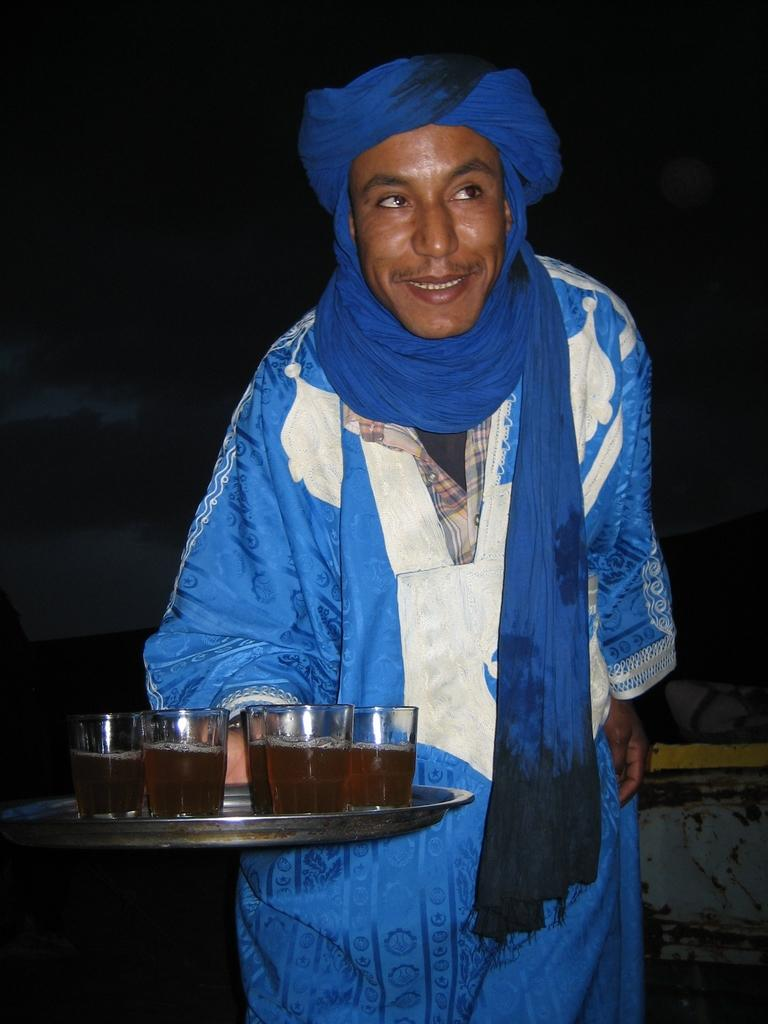Who is present in the image? There is a person in the image. What is the person wearing? The person is wearing a blue dress. What is the person holding in the image? The person is holding a plate. What is on the plate that the person is holding? There are glasses of drinks on the plate. How many cent coins are on the plate in the image? There are no cent coins present on the plate in the image. 